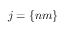<formula> <loc_0><loc_0><loc_500><loc_500>j = \left \{ n m \right \}</formula> 